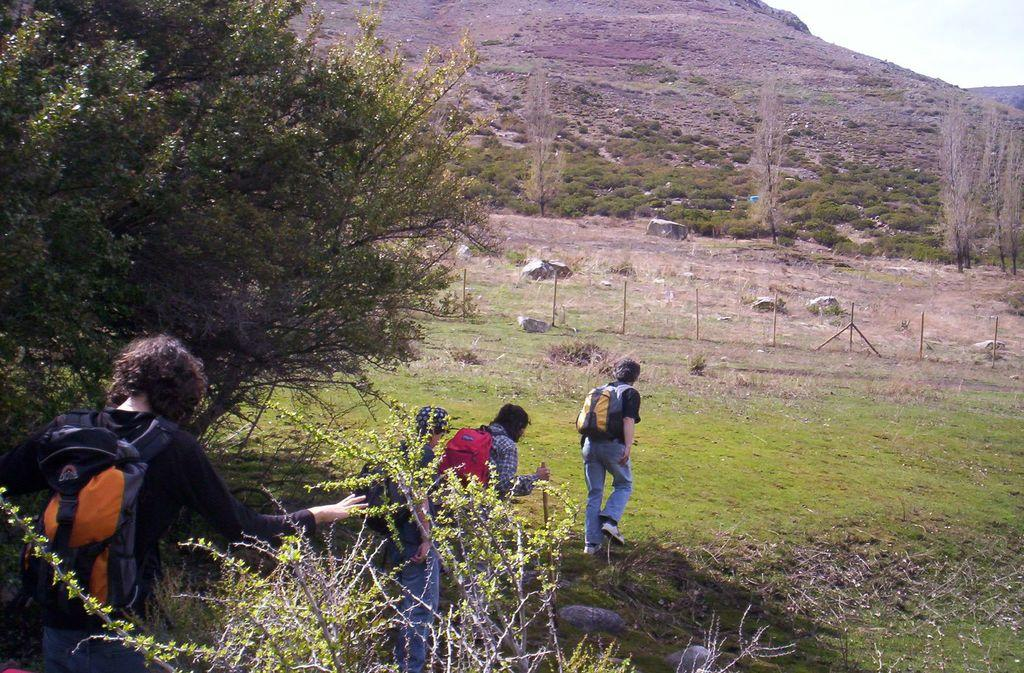Where was the photo taken? The photo was taken on the ground. What can be seen on the left side of the image? There is a plant on the left side of the image. What are the people in the image doing? The people in the image are walking. What are the people carrying while walking? The people are carrying backpacks. What can be seen in the background of the image? There is a hill, trees, and stones in the background of the image. What type of vest is the stick wearing in the image? There is no stick or vest present in the image. 